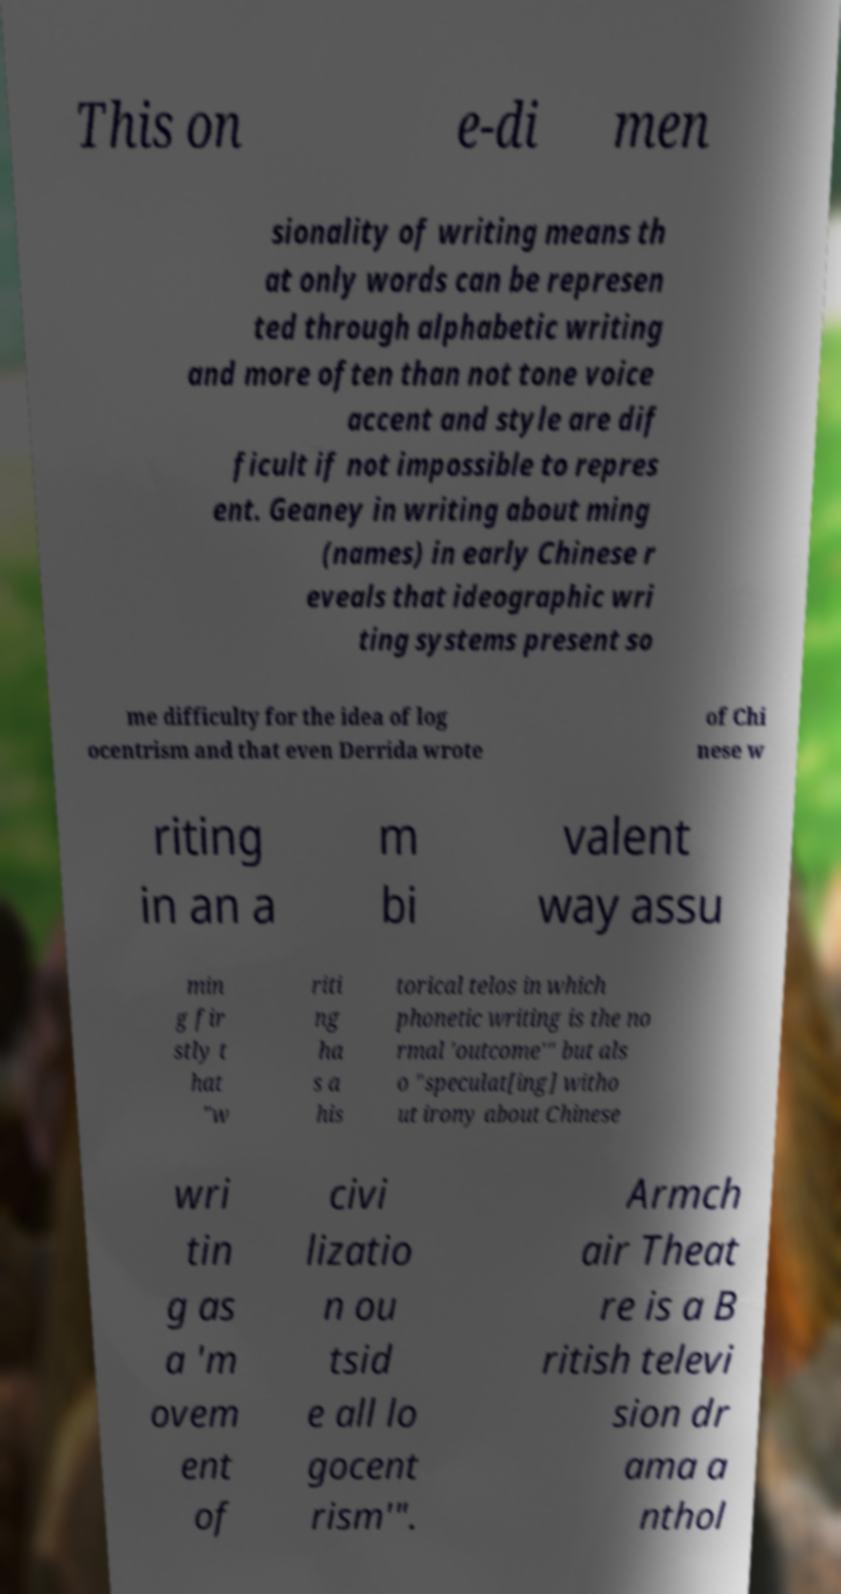Could you extract and type out the text from this image? This on e-di men sionality of writing means th at only words can be represen ted through alphabetic writing and more often than not tone voice accent and style are dif ficult if not impossible to repres ent. Geaney in writing about ming (names) in early Chinese r eveals that ideographic wri ting systems present so me difficulty for the idea of log ocentrism and that even Derrida wrote of Chi nese w riting in an a m bi valent way assu min g fir stly t hat "w riti ng ha s a his torical telos in which phonetic writing is the no rmal 'outcome'" but als o "speculat[ing] witho ut irony about Chinese wri tin g as a 'm ovem ent of civi lizatio n ou tsid e all lo gocent rism'". Armch air Theat re is a B ritish televi sion dr ama a nthol 